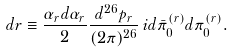<formula> <loc_0><loc_0><loc_500><loc_500>d r \equiv \frac { \alpha _ { r } d \alpha _ { r } } { 2 } \frac { d ^ { 2 6 } p _ { r } } { ( 2 \pi ) ^ { 2 6 } } \, i d \bar { \pi } _ { 0 } ^ { ( r ) } d \pi _ { 0 } ^ { ( r ) } .</formula> 